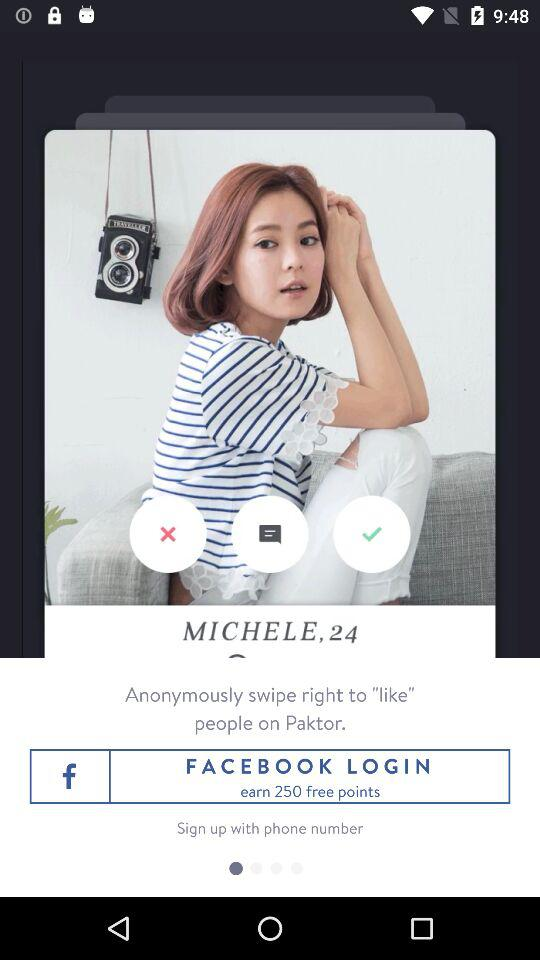What is the age? The age is 24. 